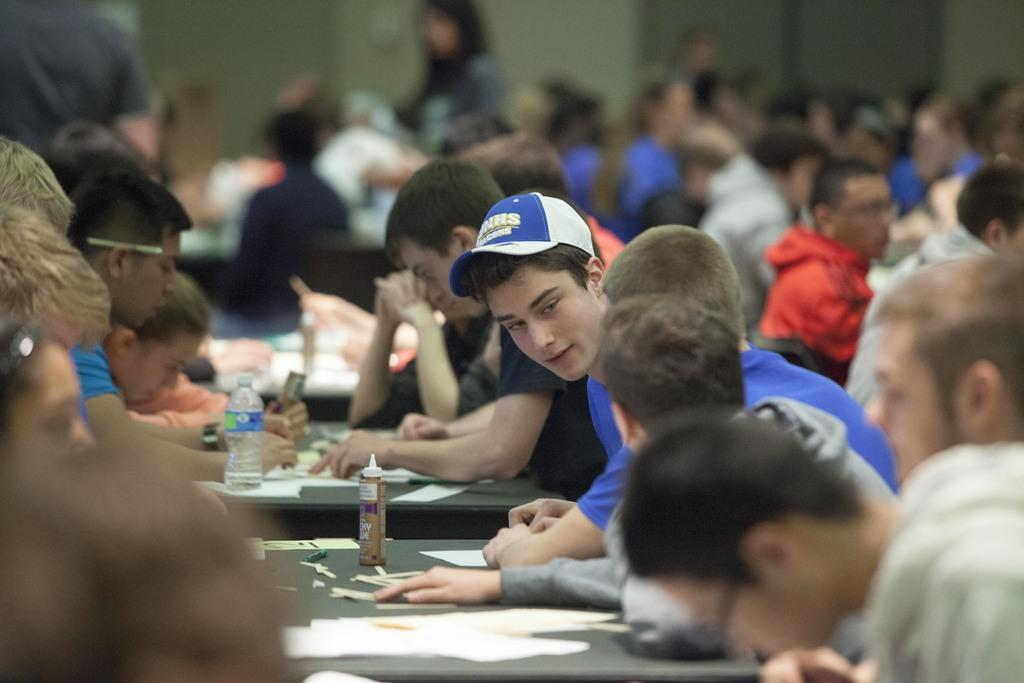What are the people in the image doing? The people in the image are sitting on chairs. What objects are present in the image that the people might be using? There are tables in the image that the people might be using. What can be seen in the background of the image? There is a wall in the background of the image. What type of calculator is being used by the people in the image? There is no calculator present in the image. 